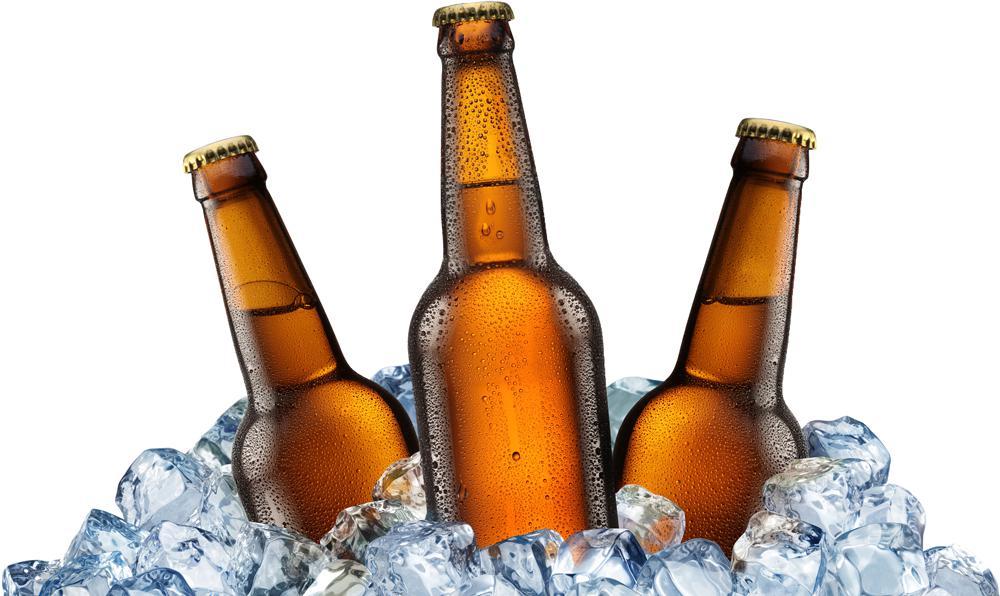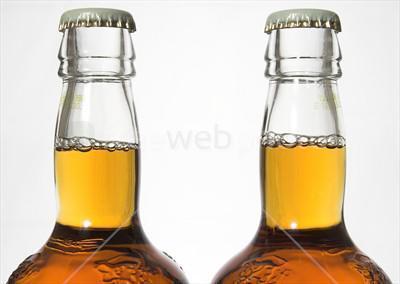The first image is the image on the left, the second image is the image on the right. For the images displayed, is the sentence "In one image, at least two beer bottles are capped and ice, but do not have a label." factually correct? Answer yes or no. Yes. The first image is the image on the left, the second image is the image on the right. Considering the images on both sides, is "Bottles are protruding from a pile of ice." valid? Answer yes or no. Yes. 